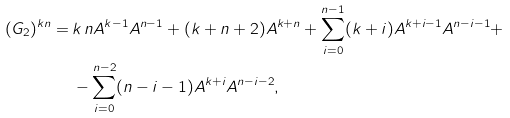Convert formula to latex. <formula><loc_0><loc_0><loc_500><loc_500>( G _ { 2 } ) ^ { k n } = \, & k \, n A ^ { k - 1 } A ^ { n - 1 } + ( k + n + 2 ) A ^ { k + n } + \sum _ { i = 0 } ^ { n - 1 } ( k + i ) A ^ { k + i - 1 } A ^ { n - i - 1 } + \\ & - \sum _ { i = 0 } ^ { n - 2 } ( n - i - 1 ) A ^ { k + i } A ^ { n - i - 2 } ,</formula> 